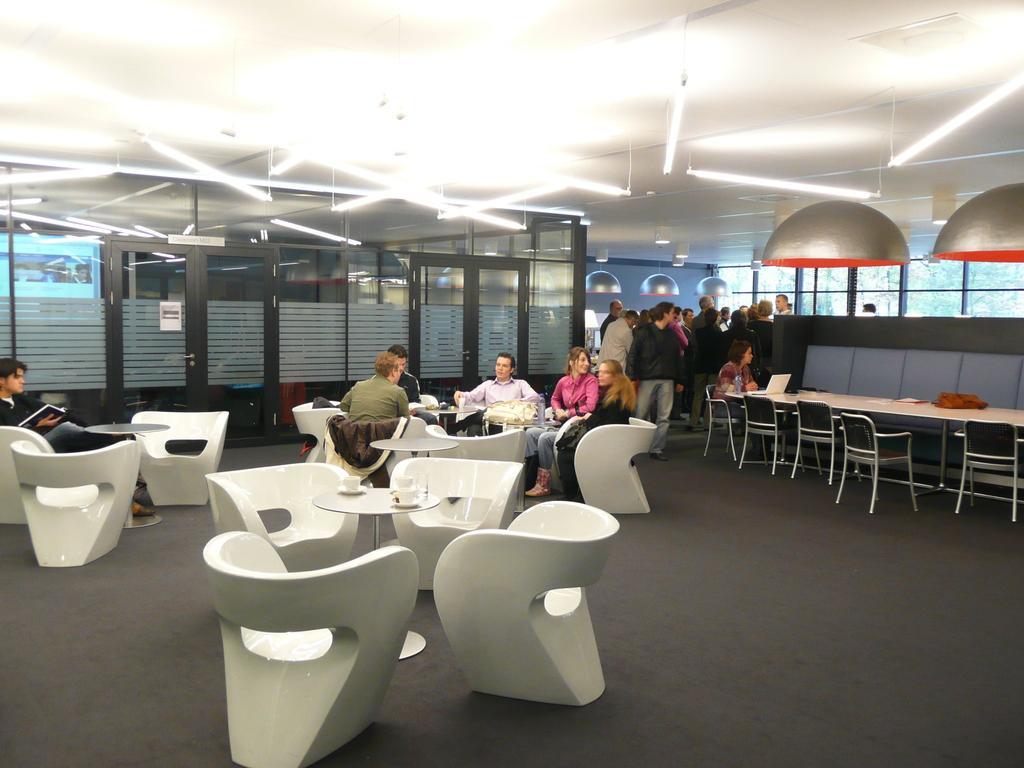Could you give a brief overview of what you see in this image? In this image I can see the floor, few chairs which are white in color on the floor, few persons sitting, few tables, few cups on the tables, few persons standing, the glass doors, the ceiling, few lights to the ceiling and few glass windows through which I can see few trees. 